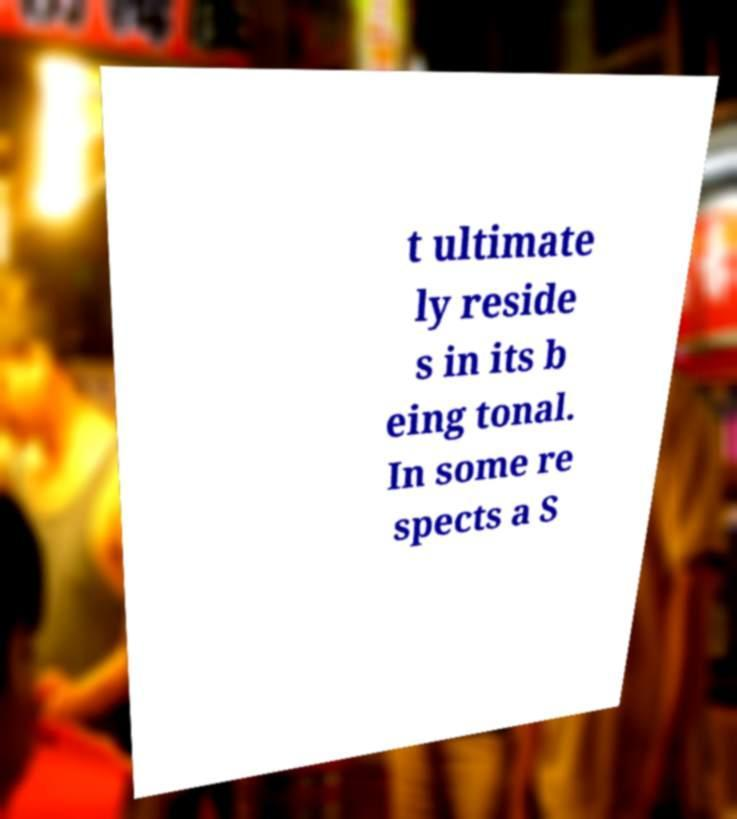Can you accurately transcribe the text from the provided image for me? t ultimate ly reside s in its b eing tonal. In some re spects a S 